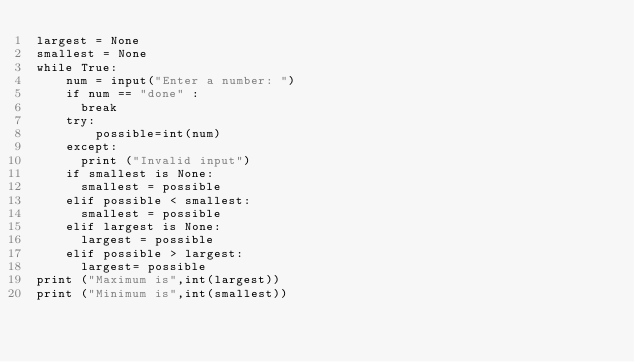<code> <loc_0><loc_0><loc_500><loc_500><_Python_>largest = None
smallest = None
while True:
    num = input("Enter a number: ")
    if num == "done" : 
    	break
    try:
        possible=int(num)
    except:
    	print ("Invalid input")
    if smallest is None:
    	smallest = possible
    elif possible < smallest:
    	smallest = possible
    elif largest is None:
    	largest = possible
    elif possible > largest:
    	largest= possible
print ("Maximum is",int(largest))
print ("Minimum is",int(smallest))</code> 